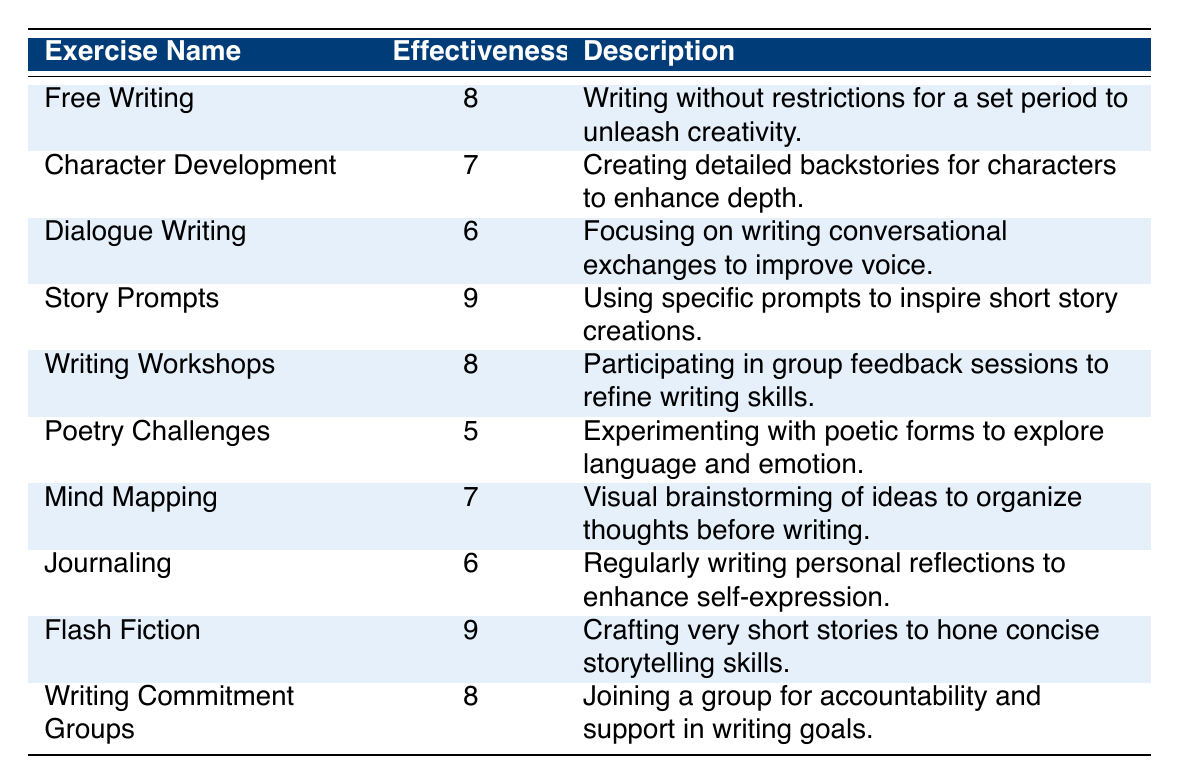What is the effectiveness rating of "Story Prompts"? The table directly lists "Story Prompts" with an effectiveness rating of 9.
Answer: 9 Which writing exercise has the lowest effectiveness rating? By scanning the table, "Poetry Challenges" is the exercise with the lowest effectiveness rating at 5.
Answer: Poetry Challenges What is the effectiveness rating for "Free Writing"? The table clearly indicates that "Free Writing" has an effectiveness rating of 8.
Answer: 8 How many exercises have an effectiveness rating of 8 or higher? The exercises with ratings of 8 or higher are "Free Writing", "Story Prompts", "Writing Workshops", "Flash Fiction", and "Writing Commitment Groups". Counting these gives a total of 5 exercises.
Answer: 5 Is "Journaling" rated higher than "Dialogue Writing"? The effectiveness rating of "Journaling" is 6, while "Dialogue Writing" also has a rating of 6. Therefore, they are equal.
Answer: No What is the average effectiveness rating of all the exercises? The ratings are 8, 7, 6, 9, 8, 5, 7, 6, 9, and 8. Adding these gives 8 + 7 + 6 + 9 + 8 + 5 + 7 + 6 + 9 + 8 = 79. There are 10 exercises, so the average is 79 / 10 = 7.9.
Answer: 7.9 Which type of exercise focuses on improving voice through conversational exchanges? The table specifies "Dialogue Writing" as the exercise that concentrates on writing conversational exchanges to improve voice.
Answer: Dialogue Writing Are there more exercises that focus on character development than those focusing on poetry? "Character Development" has an effectiveness rating of 7, while "Poetry Challenges" has a rating of 5. Only one exercise focuses on character development explicitly, while there are multiple types of poetry exercises, including "Poetry Challenges". Thus, in this context, the comparison of character development to a singular poetry exercise does not lead to more effective exercises in poetry.
Answer: No How does the effectiveness rating of "Flash Fiction" compare to that of "Mind Mapping"? "Flash Fiction" has a rating of 9, while "Mind Mapping" has a rating of 7. Thus, "Flash Fiction" is rated higher.
Answer: Flash Fiction is rated higher If a participant wanted to work on both character development and dialogue, which two exercises should they choose? They should choose "Character Development" and "Dialogue Writing", as these are the respective exercises targeting those areas.
Answer: Character Development and Dialogue Writing 